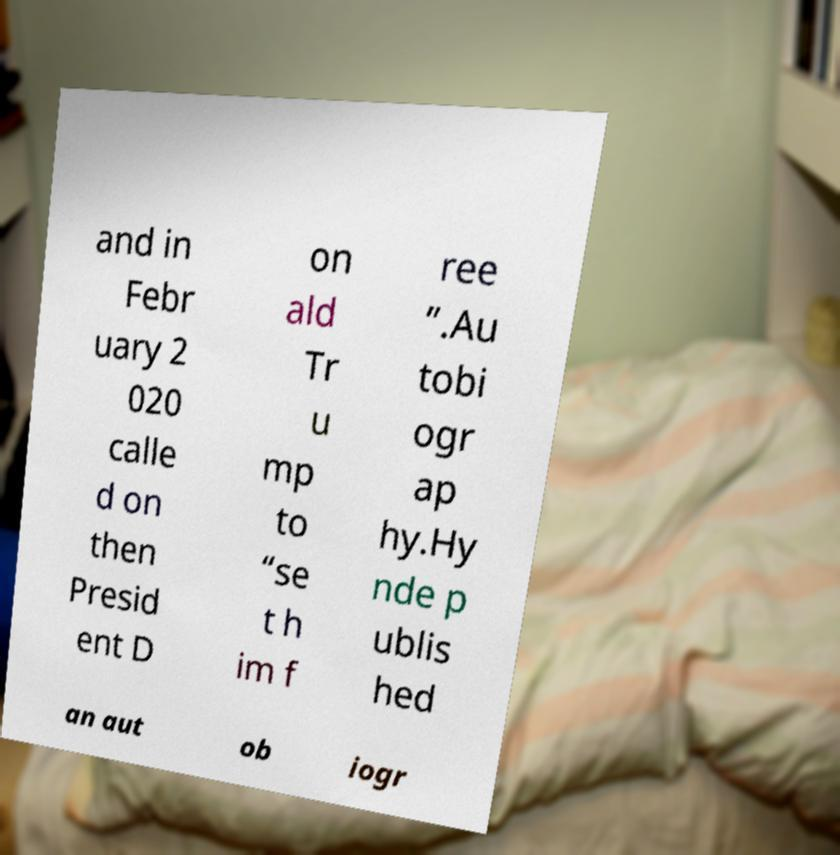Can you accurately transcribe the text from the provided image for me? and in Febr uary 2 020 calle d on then Presid ent D on ald Tr u mp to “se t h im f ree ”.Au tobi ogr ap hy.Hy nde p ublis hed an aut ob iogr 